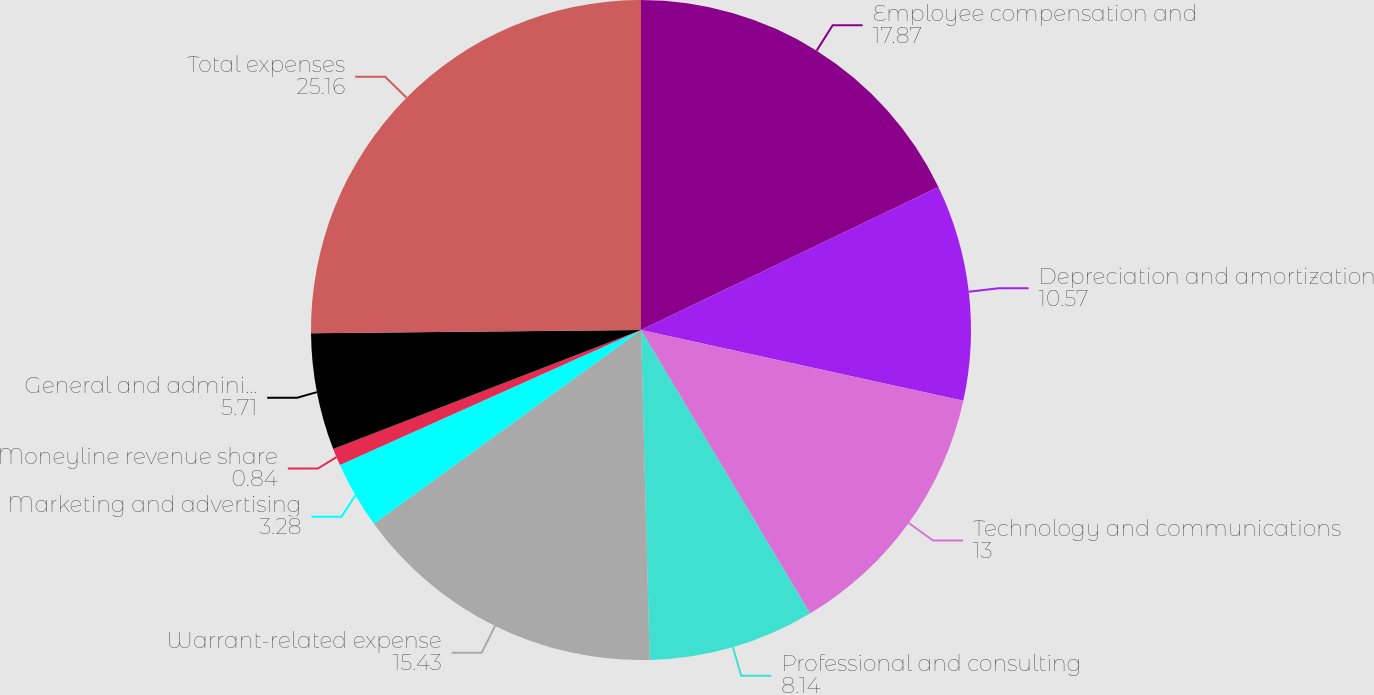Convert chart. <chart><loc_0><loc_0><loc_500><loc_500><pie_chart><fcel>Employee compensation and<fcel>Depreciation and amortization<fcel>Technology and communications<fcel>Professional and consulting<fcel>Warrant-related expense<fcel>Marketing and advertising<fcel>Moneyline revenue share<fcel>General and administrative<fcel>Total expenses<nl><fcel>17.87%<fcel>10.57%<fcel>13.0%<fcel>8.14%<fcel>15.43%<fcel>3.28%<fcel>0.84%<fcel>5.71%<fcel>25.16%<nl></chart> 